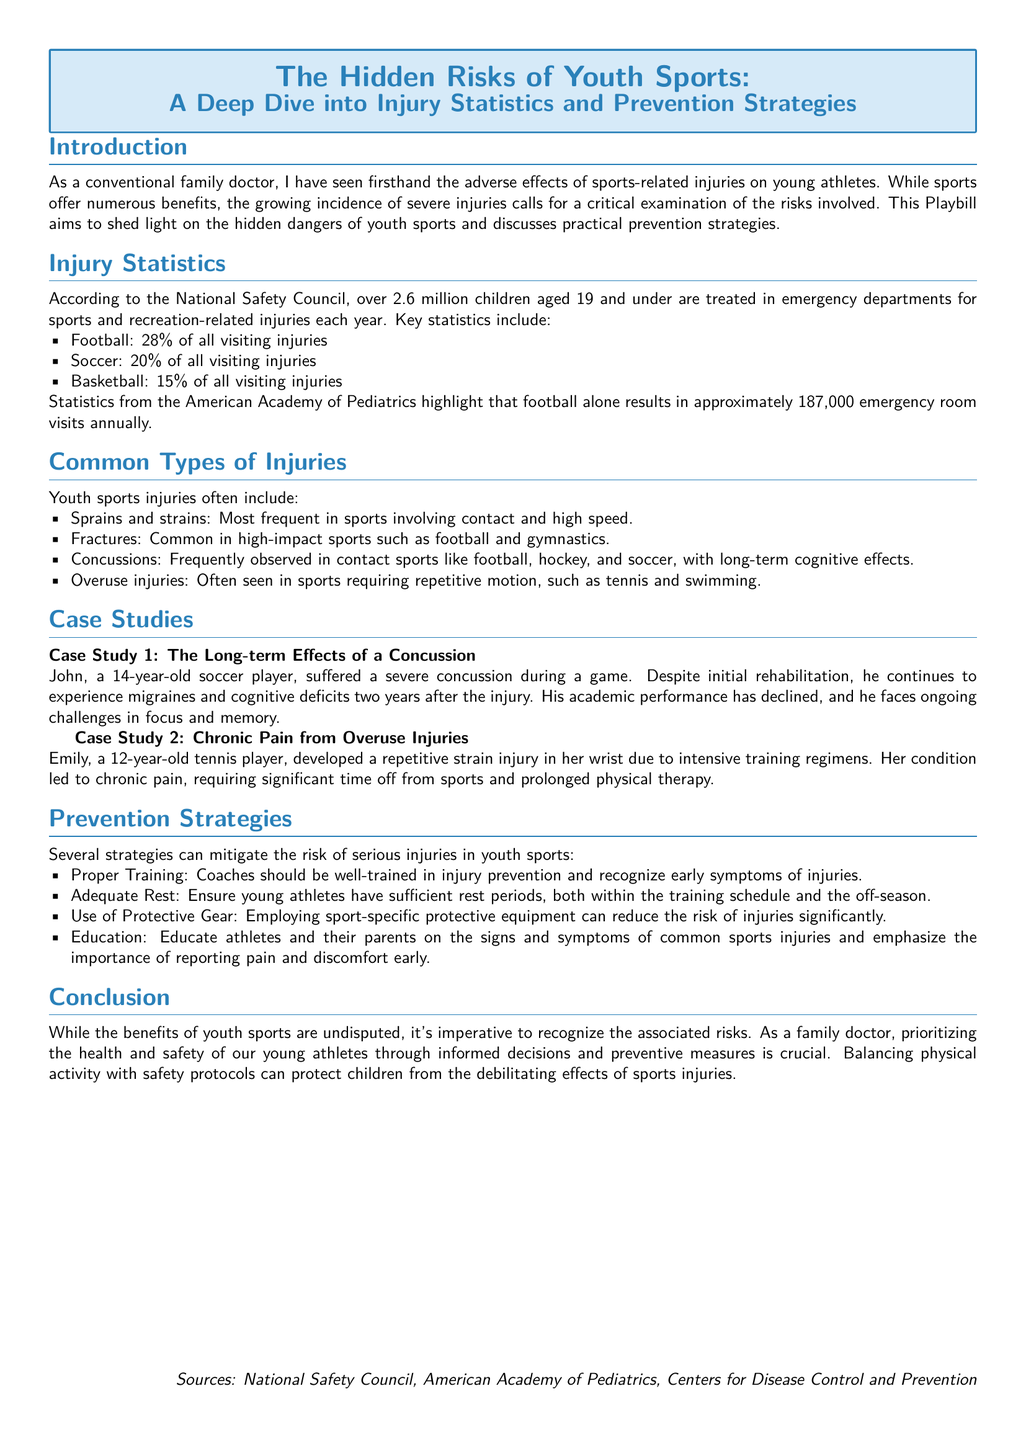What is the main focus of the Playbill? The main focus of the Playbill is to examine the hidden risks associated with youth sports, particularly injuries and prevention strategies.
Answer: Hidden risks of youth sports How many children are treated for sports-related injuries each year? According to the National Safety Council, over 2.6 million children aged 19 and under are treated annually for sports-related injuries.
Answer: 2.6 million What percentage of injuries are due to football? The Playbill states that 28% of all visiting injuries are attributed to football.
Answer: 28% What type of injury is frequently observed in contact sports? The Playbill mentions concussions as a common injury in contact sports like football and hockey.
Answer: Concussions What case study discusses chronic pain from overuse injuries? The case study involving Emily, a 12-year-old tennis player, addresses chronic pain from overuse injuries.
Answer: Emily's case study What is one prevention strategy recommended in the Playbill? One recommended strategy is using sport-specific protective equipment to reduce the risk of injuries.
Answer: Use of Protective Gear What is a common effect mentioned in the case study about concussions? The case study indicates ongoing migraines and cognitive deficits as long-term effects of a concussion.
Answer: Migraines and cognitive deficits How many emergency room visits does football result in annually? Football results in approximately 187,000 emergency room visits each year according to the American Academy of Pediatrics.
Answer: 187,000 